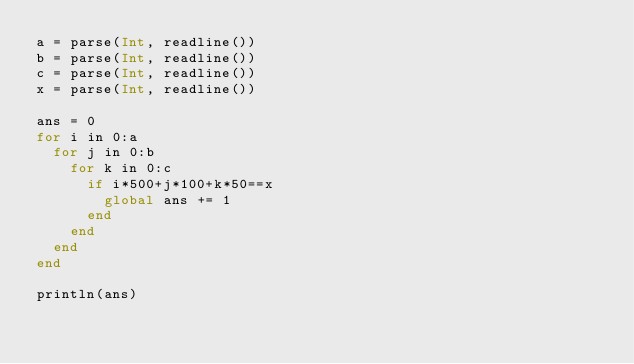Convert code to text. <code><loc_0><loc_0><loc_500><loc_500><_Julia_>a = parse(Int, readline())
b = parse(Int, readline())
c = parse(Int, readline())
x = parse(Int, readline())

ans = 0
for i in 0:a
  for j in 0:b
    for k in 0:c
      if i*500+j*100+k*50==x
        global ans += 1
      end
    end
  end
end

println(ans)</code> 